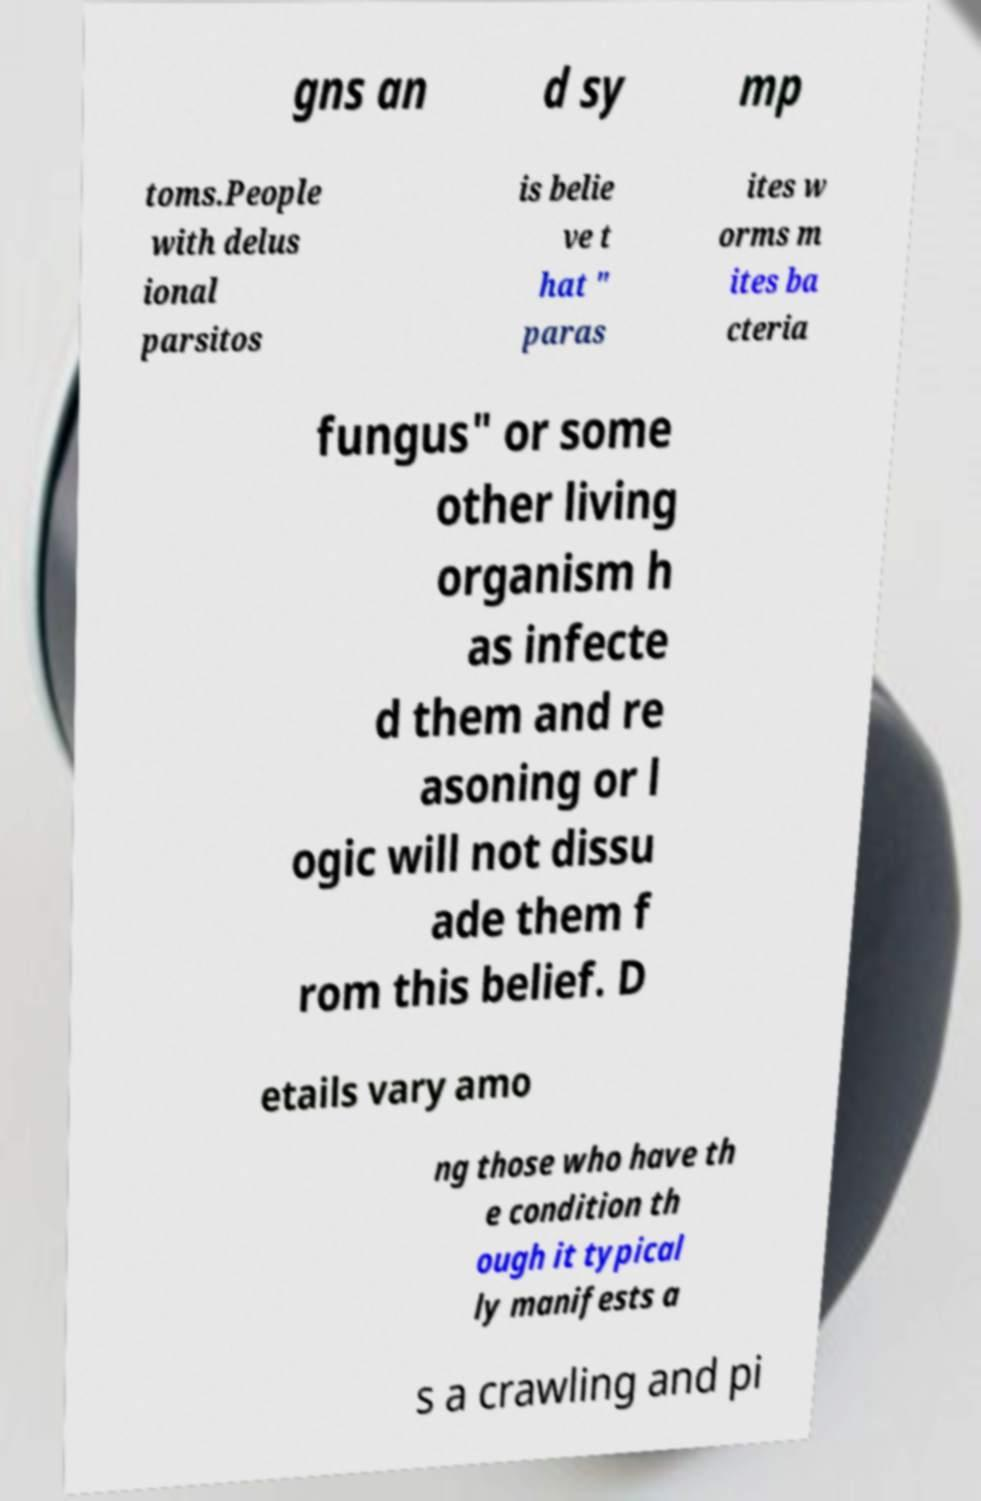Please read and relay the text visible in this image. What does it say? gns an d sy mp toms.People with delus ional parsitos is belie ve t hat " paras ites w orms m ites ba cteria fungus" or some other living organism h as infecte d them and re asoning or l ogic will not dissu ade them f rom this belief. D etails vary amo ng those who have th e condition th ough it typical ly manifests a s a crawling and pi 